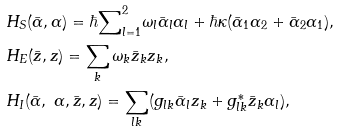Convert formula to latex. <formula><loc_0><loc_0><loc_500><loc_500>& H _ { S } ( \bar { \alpha } , \alpha ) = \hbar { \sum } _ { l = 1 } ^ { 2 } \omega _ { l } \bar { \alpha } _ { l } \alpha _ { l } + \hbar { \kappa } ( \bar { \alpha } _ { 1 } \alpha _ { 2 } + \bar { \alpha } _ { 2 } \alpha _ { 1 } ) , \\ & H _ { E } ( \bar { z } , z ) = \sum _ { k } \omega _ { k } \bar { z } _ { k } z _ { k } , \\ & H _ { I } ( \bar { \alpha } , \ \alpha , \bar { z } , z ) = \sum _ { l k } ( g _ { l k } \bar { \alpha } _ { l } z _ { k } + g _ { l k } ^ { \ast } \bar { z } _ { k } \alpha _ { l } ) ,</formula> 